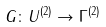Convert formula to latex. <formula><loc_0><loc_0><loc_500><loc_500>G \colon U ^ { ( 2 ) } \to \Gamma ^ { ( 2 ) }</formula> 